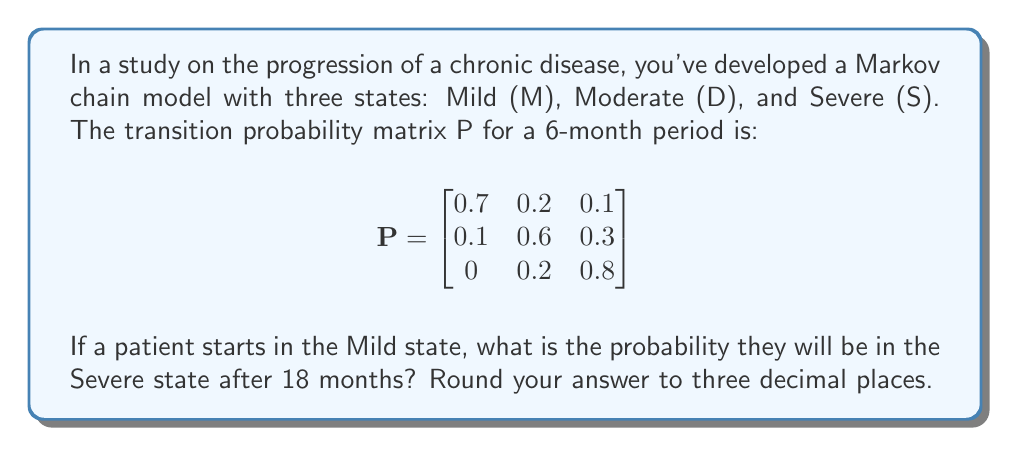Provide a solution to this math problem. To solve this problem, we need to use matrix multiplication to find the transition probabilities after 18 months. Since each transition represents a 6-month period, we need to multiply the matrix by itself three times.

Step 1: Calculate $P^3$
$$P^3 = P \times P \times P$$

Step 2: Multiply the matrices
$$P^2 = \begin{bmatrix}
0.7 & 0.2 & 0.1 \\
0.1 & 0.6 & 0.3 \\
0 & 0.2 & 0.8
\end{bmatrix} \times 
\begin{bmatrix}
0.7 & 0.2 & 0.1 \\
0.1 & 0.6 & 0.3 \\
0 & 0.2 & 0.8
\end{bmatrix} = 
\begin{bmatrix}
0.52 & 0.30 & 0.18 \\
0.13 & 0.46 & 0.41 \\
0.02 & 0.28 & 0.70
\end{bmatrix}$$

$$P^3 = P^2 \times P = 
\begin{bmatrix}
0.52 & 0.30 & 0.18 \\
0.13 & 0.46 & 0.41 \\
0.02 & 0.28 & 0.70
\end{bmatrix} \times
\begin{bmatrix}
0.7 & 0.2 & 0.1 \\
0.1 & 0.6 & 0.3 \\
0 & 0.2 & 0.8
\end{bmatrix} = 
\begin{bmatrix}
0.401 & 0.334 & 0.265 \\
0.139 & 0.382 & 0.479 \\
0.034 & 0.306 & 0.660
\end{bmatrix}$$

Step 3: Interpret the result
The first row of $P^3$ represents the probabilities of transitioning from the Mild state to each state after 18 months. The probability of transitioning from Mild to Severe is given by the element in the first row, third column of $P^3$.

Step 4: Round to three decimal places
0.265 rounded to three decimal places is 0.265.
Answer: 0.265 